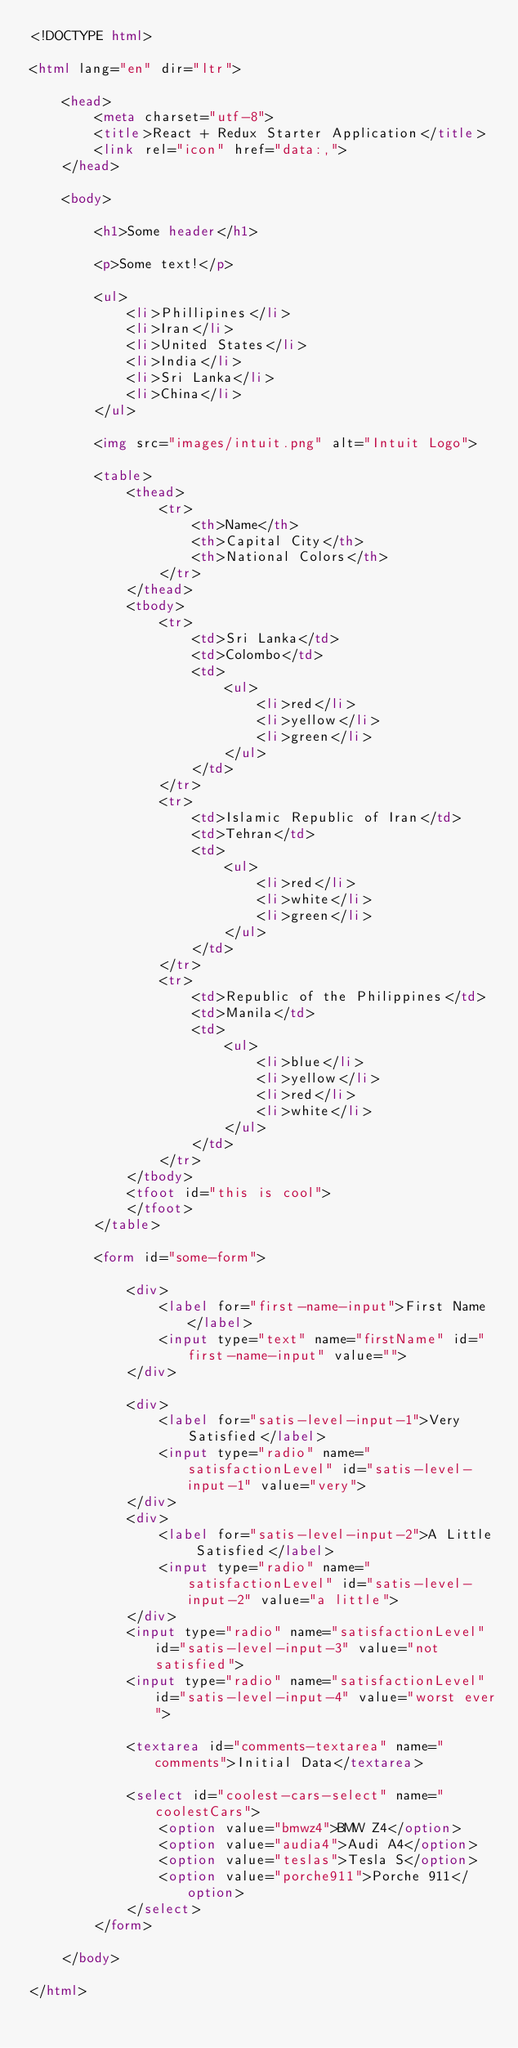Convert code to text. <code><loc_0><loc_0><loc_500><loc_500><_HTML_><!DOCTYPE html>

<html lang="en" dir="ltr">

	<head>
        <meta charset="utf-8">
		<title>React + Redux Starter Application</title>
        <link rel="icon" href="data:,">
    </head>

	<body>

        <h1>Some header</h1>

        <p>Some text!</p>

        <ul>
            <li>Phillipines</li>
            <li>Iran</li>
            <li>United States</li>
            <li>India</li>
            <li>Sri Lanka</li>
            <li>China</li>
        </ul>

        <img src="images/intuit.png" alt="Intuit Logo">

        <table>
            <thead>
                <tr>
                    <th>Name</th>
                    <th>Capital City</th>
                    <th>National Colors</th>
                </tr>
            </thead>
            <tbody>
                <tr>
                    <td>Sri Lanka</td>
                    <td>Colombo</td>
                    <td>
                        <ul>
                            <li>red</li>
                            <li>yellow</li>
                            <li>green</li>
                        </ul>
                    </td>
                </tr>
                <tr>
                    <td>Islamic Republic of Iran</td>
                    <td>Tehran</td>
                    <td>
                        <ul>
                            <li>red</li>
                            <li>white</li>
                            <li>green</li>
                        </ul>
                    </td>
                </tr>
                <tr>
                    <td>Republic of the Philippines</td>
                    <td>Manila</td>
                    <td>
                        <ul>
                            <li>blue</li>
                            <li>yellow</li>
                            <li>red</li>
                            <li>white</li>
                        </ul>
                    </td>
                </tr>
            </tbody>
            <tfoot id="this is cool">
            </tfoot>
        </table>

        <form id="some-form">

            <div>
                <label for="first-name-input">First Name</label>
                <input type="text" name="firstName" id="first-name-input" value="">
            </div>

            <div>
                <label for="satis-level-input-1">Very Satisfied</label>
                <input type="radio" name="satisfactionLevel" id="satis-level-input-1" value="very">
            </div>
            <div>
                <label for="satis-level-input-2">A Little Satisfied</label>
                <input type="radio" name="satisfactionLevel" id="satis-level-input-2" value="a little">
            </div>
            <input type="radio" name="satisfactionLevel" id="satis-level-input-3" value="not satisfied">
            <input type="radio" name="satisfactionLevel" id="satis-level-input-4" value="worst ever">

            <textarea id="comments-textarea" name="comments">Initial Data</textarea>

            <select id="coolest-cars-select" name="coolestCars">
                <option value="bmwz4">BMW Z4</option>
                <option value="audia4">Audi A4</option>
                <option value="teslas">Tesla S</option>
                <option value="porche911">Porche 911</option>
            </select>
        </form>

	</body>

</html>
</code> 